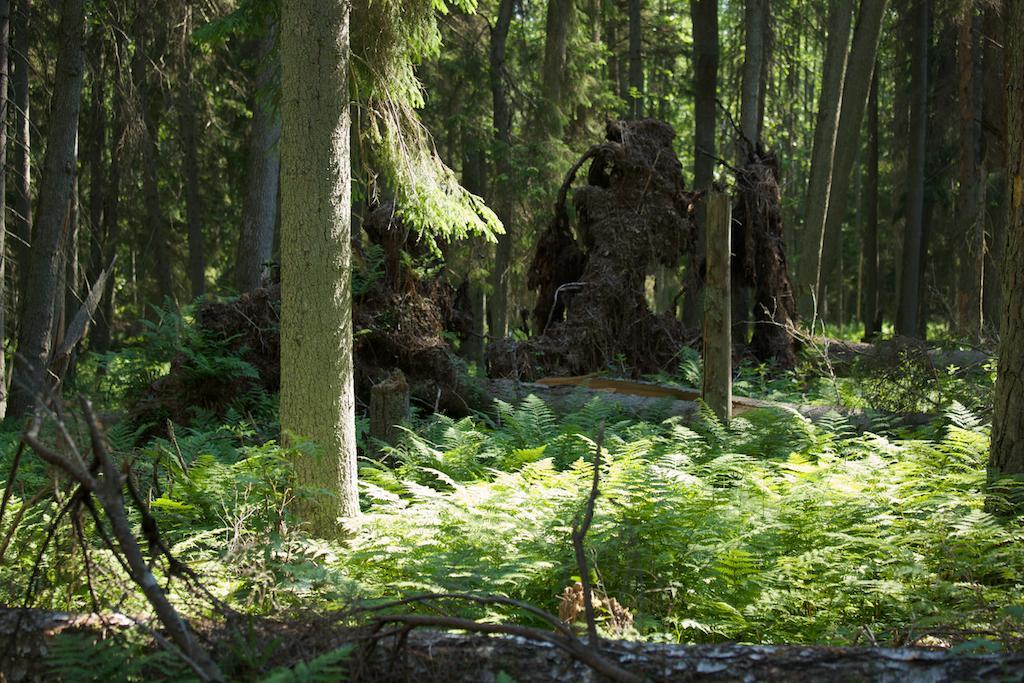How would you summarize this image in a sentence or two? In this image I can see few plants which are green in color and few trees. I can see few fallen trees which are brown in color. 